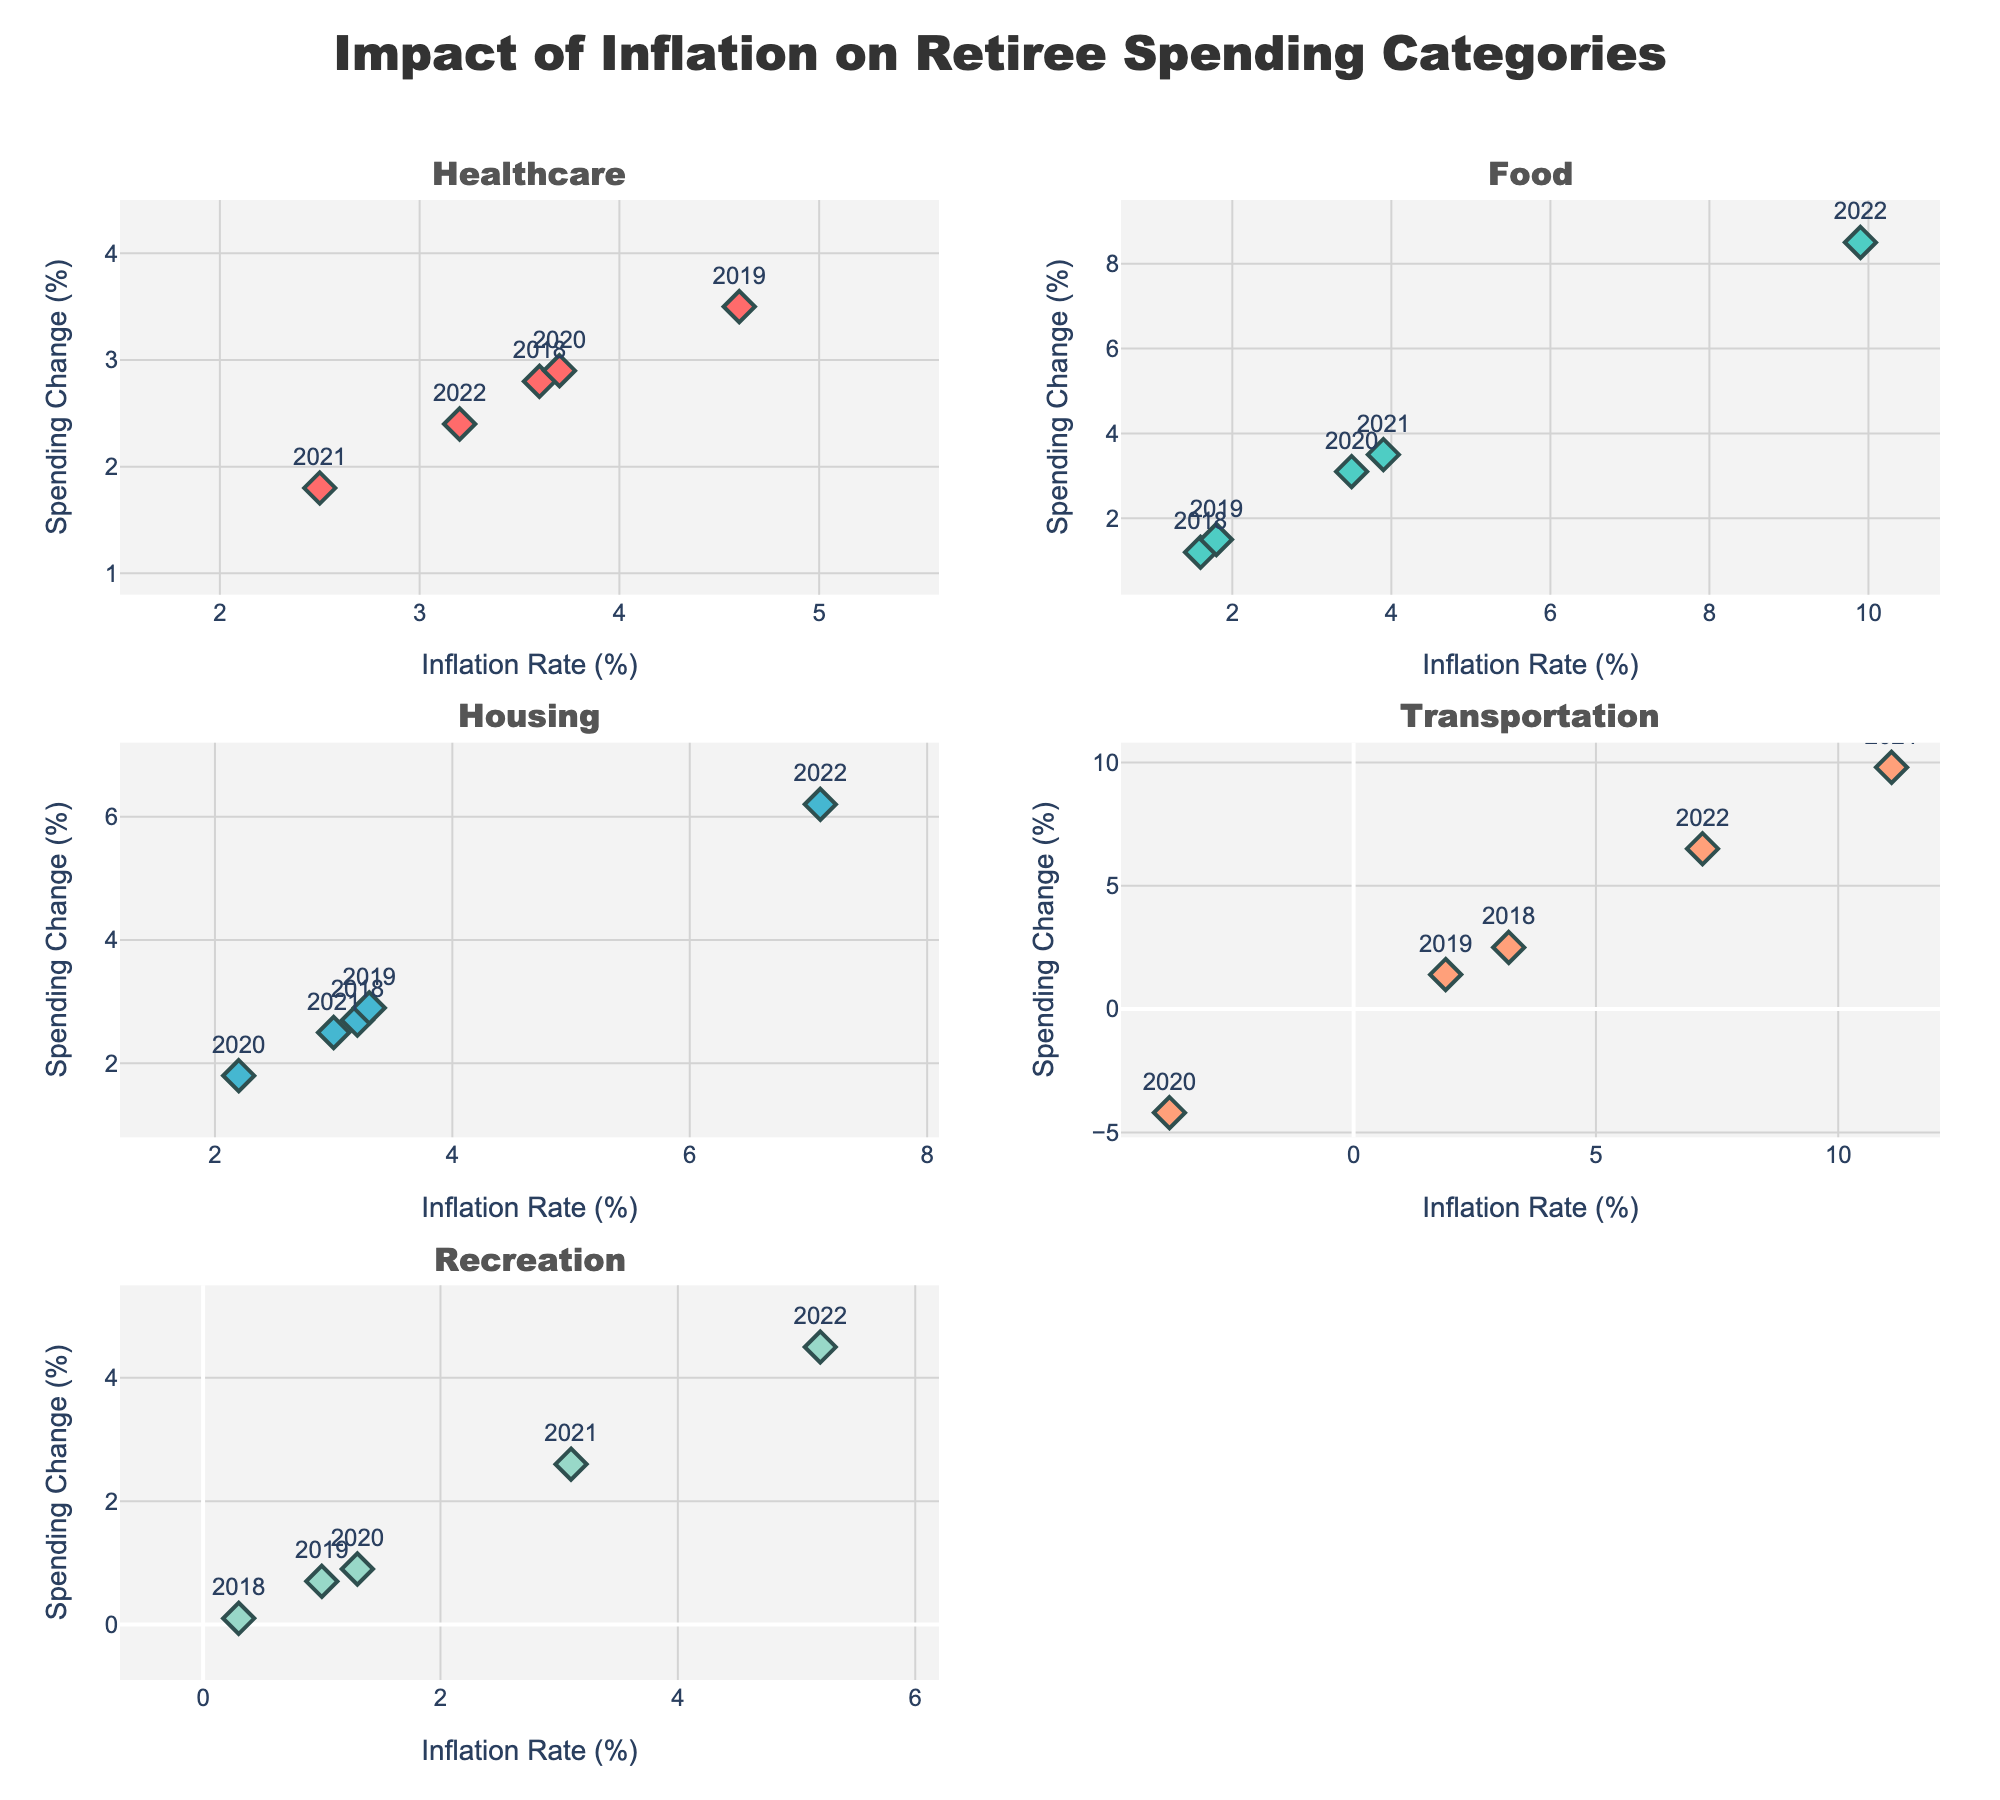What is the title of the figure? The title of the figure is located at the top and provides a brief summary of what the figure represents.
Answer: Religious Demographics in Major Punjab Cities Which city has the largest population bubble? By looking at the size of the bubbles, the largest one represents the city with the highest population.
Answer: Ludhiana Which religion has the most prominent presence in Patiala? The figure shows the percentage distribution of religions in each city; the tallest bubble in Patiala indicates the most prominent religion.
Answer: Hindu Compare the Sikh populations of Moga and Bathinda. Which city has a higher percentage of Sikhs? By analyzing the height of the Sikh percentage bubbles in Moga and Bathinda, we see which one is higher.
Answer: Moga How does the proportion of Hindus in Hoshiarpur compare to that in Ludhiana? Compare the height of the Hindu percentage bubbles between Hoshiarpur and Ludhiana to see which is higher.
Answer: Ludhiana Which city has the smallest bubble, and what does that indicate? The smallest bubble represents the city with the lowest population.
Answer: Firozpur What is the range of the y-axis percentage values? The range of the y-axis, labeled "Percentage," is indicated at the side of the figure.
Answer: 0% to 100% How do the percentages of Muslims in Jalandhar and Pathankot compare? Compare the height of the Muslim percentage bubbles for Jalandhar and Pathankot to identify which is higher.
Answer: Jalandhar Identify a city where both Hindus and Sikhs have nearly equal percentages. Look for cities with Hindu and Sikh bubbles of similar heights.
Answer: Amritsar In terms of representation in the figure, how does the "Other" category distribution appear overall? By examining the "Other" category bubbles across all cities, we see their relative height and number.
Answer: Less prominent 